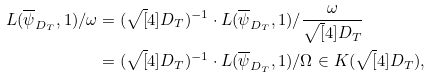Convert formula to latex. <formula><loc_0><loc_0><loc_500><loc_500>L ( \overline { \psi } _ { D _ { T } } , 1 ) / \omega & = ( \sqrt { [ } 4 ] { D _ { T } } ) ^ { - 1 } \cdot L ( \overline { \psi } _ { D _ { T } } , 1 ) / \frac { \omega } { \sqrt { [ } 4 ] { D _ { T } } } \\ & = ( \sqrt { [ } 4 ] { D _ { T } } ) ^ { - 1 } \cdot L ( \overline { \psi } _ { D _ { T } } , 1 ) / \Omega \in K ( \sqrt { [ } 4 ] { D _ { T } } ) ,</formula> 